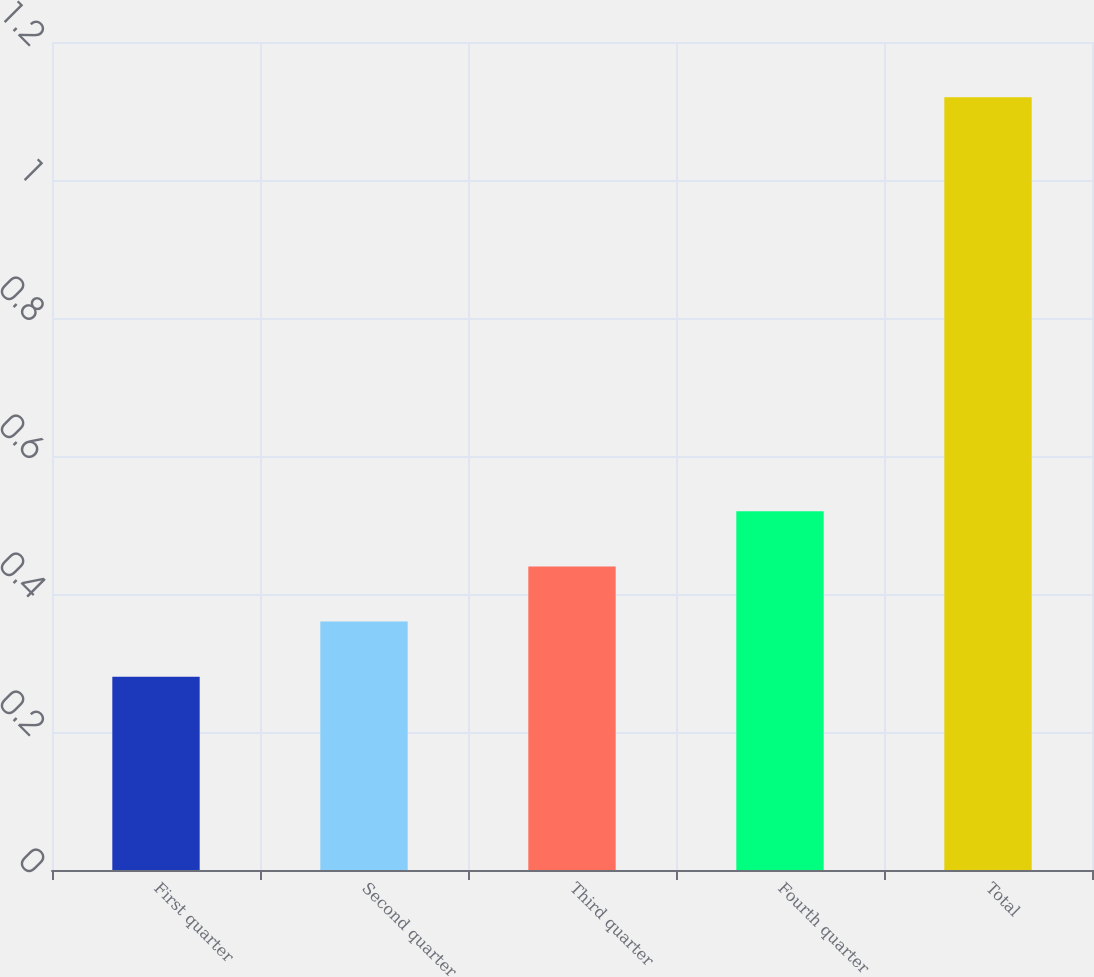Convert chart. <chart><loc_0><loc_0><loc_500><loc_500><bar_chart><fcel>First quarter<fcel>Second quarter<fcel>Third quarter<fcel>Fourth quarter<fcel>Total<nl><fcel>0.28<fcel>0.36<fcel>0.44<fcel>0.52<fcel>1.12<nl></chart> 